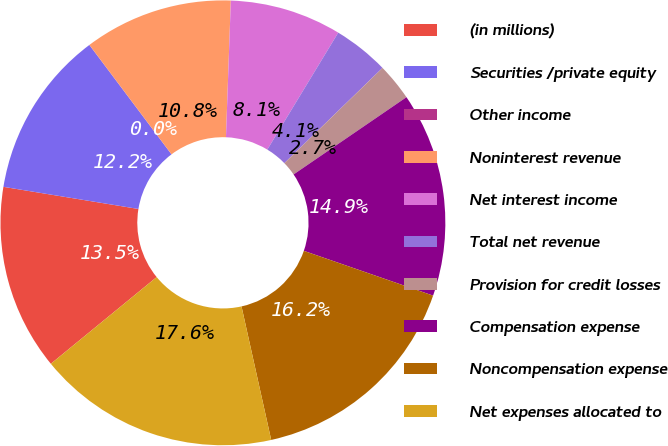Convert chart. <chart><loc_0><loc_0><loc_500><loc_500><pie_chart><fcel>(in millions)<fcel>Securities /private equity<fcel>Other income<fcel>Noninterest revenue<fcel>Net interest income<fcel>Total net revenue<fcel>Provision for credit losses<fcel>Compensation expense<fcel>Noncompensation expense<fcel>Net expenses allocated to<nl><fcel>13.51%<fcel>12.16%<fcel>0.01%<fcel>10.81%<fcel>8.11%<fcel>4.06%<fcel>2.71%<fcel>14.86%<fcel>16.21%<fcel>17.56%<nl></chart> 